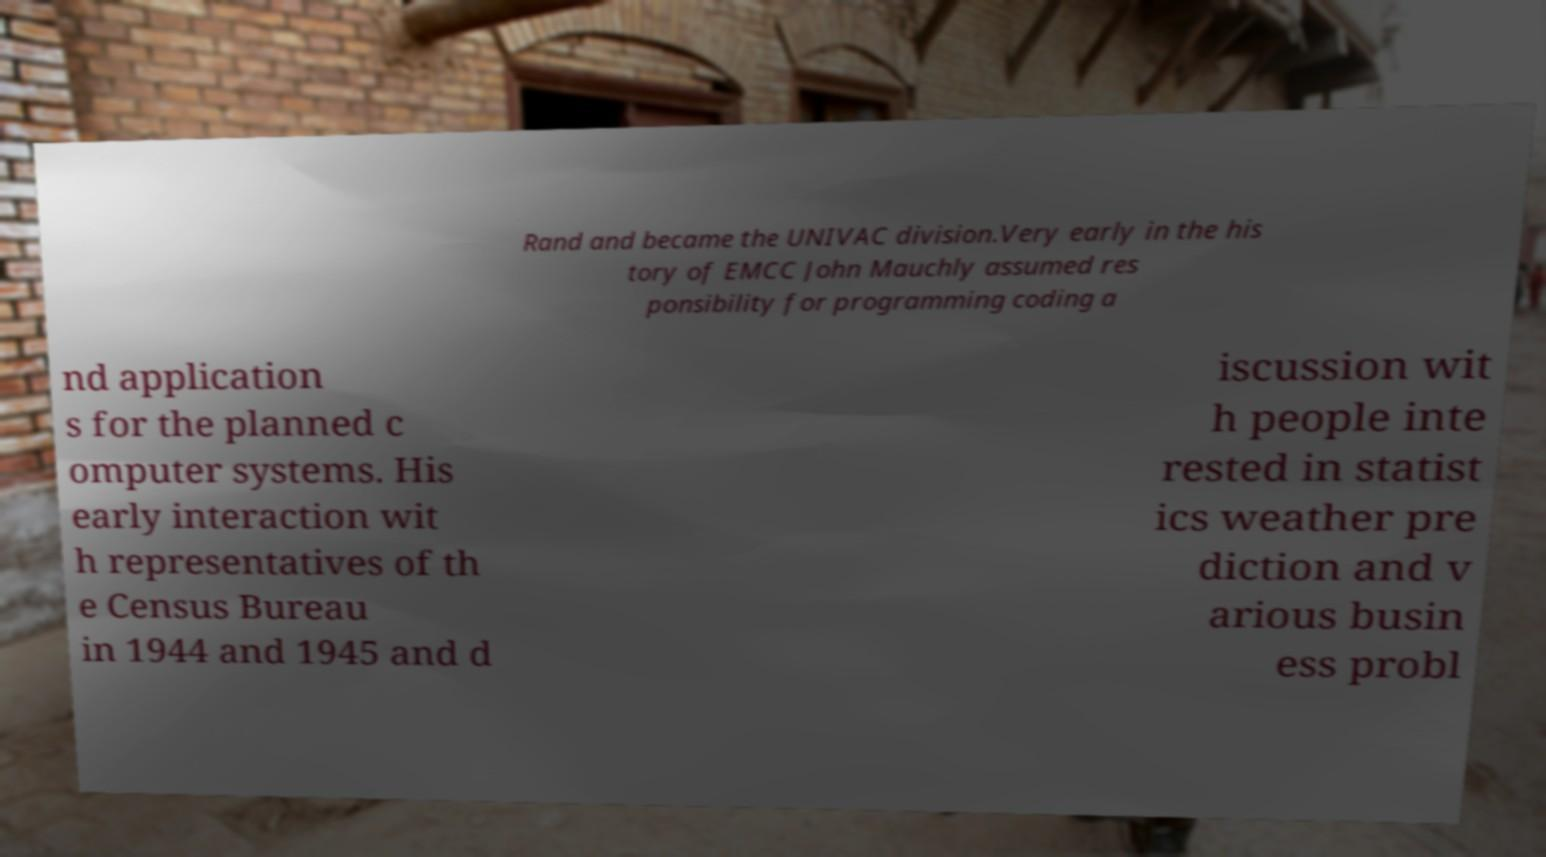Please identify and transcribe the text found in this image. Rand and became the UNIVAC division.Very early in the his tory of EMCC John Mauchly assumed res ponsibility for programming coding a nd application s for the planned c omputer systems. His early interaction wit h representatives of th e Census Bureau in 1944 and 1945 and d iscussion wit h people inte rested in statist ics weather pre diction and v arious busin ess probl 